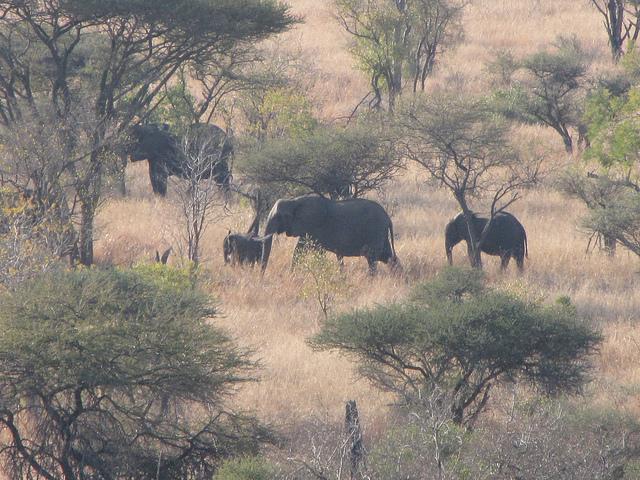How many elephants can you see?
Give a very brief answer. 3. 